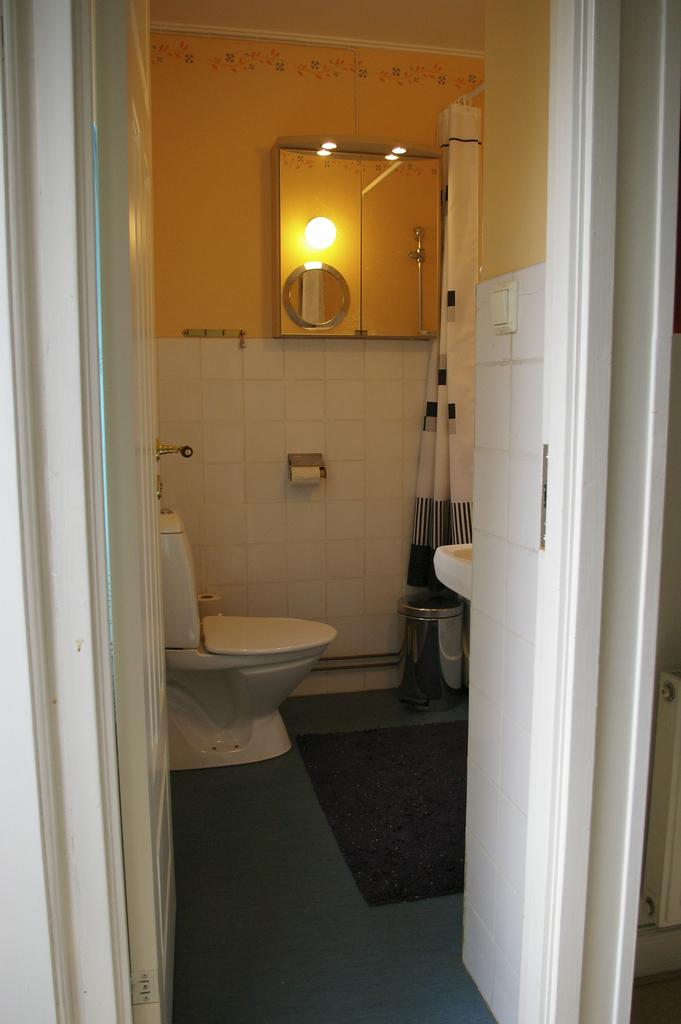What type of toilet is present in the image? There is a flush toilet in the image. What is located near the toilet? There is a paper roll in the image. What is used for washing hands in the image? A sink is visible in the image. What is used for personal grooming in the image? There is a mirror in the image. What is on the floor in the image? A mat is on the floor in the image. What is used for disposing of waste in the image? There is a trash can in front of the sink in the image. What type of knee can be seen in the image? There are no knees visible in the image; it features a bathroom setting with a toilet, paper roll, sink, mirror, mat, and trash can. 